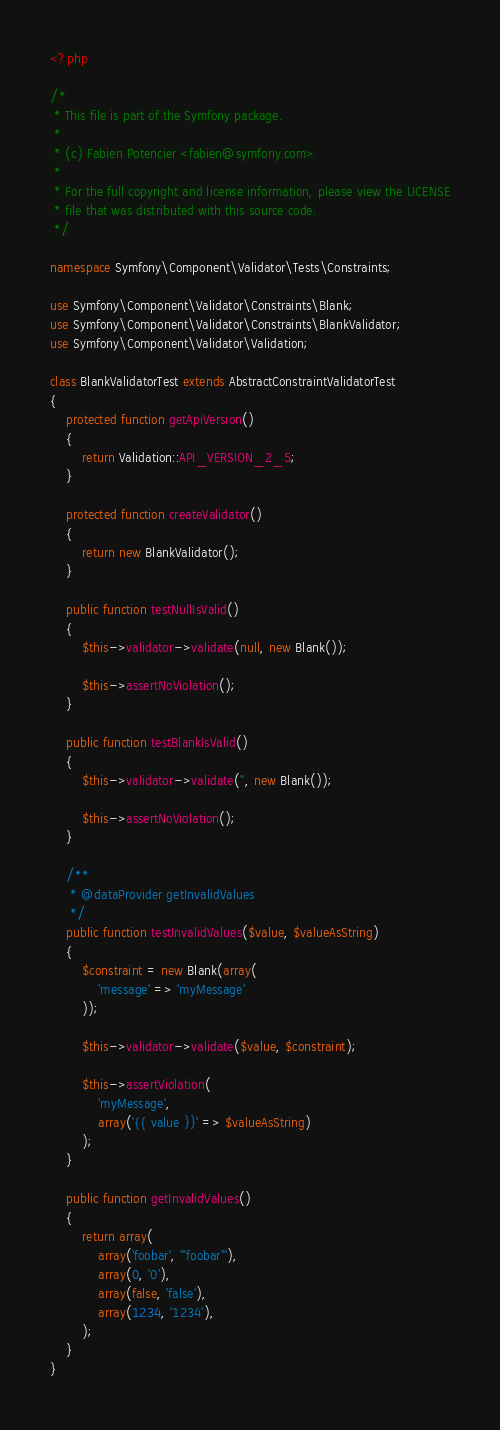Convert code to text. <code><loc_0><loc_0><loc_500><loc_500><_PHP_><?php

/*
 * This file is part of the Symfony package.
 *
 * (c) Fabien Potencier <fabien@symfony.com>
 *
 * For the full copyright and license information, please view the LICENSE
 * file that was distributed with this source code.
 */

namespace Symfony\Component\Validator\Tests\Constraints;

use Symfony\Component\Validator\Constraints\Blank;
use Symfony\Component\Validator\Constraints\BlankValidator;
use Symfony\Component\Validator\Validation;

class BlankValidatorTest extends AbstractConstraintValidatorTest
{
    protected function getApiVersion()
    {
        return Validation::API_VERSION_2_5;
    }

    protected function createValidator()
    {
        return new BlankValidator();
    }

    public function testNullIsValid()
    {
        $this->validator->validate(null, new Blank());

        $this->assertNoViolation();
    }

    public function testBlankIsValid()
    {
        $this->validator->validate('', new Blank());

        $this->assertNoViolation();
    }

    /**
     * @dataProvider getInvalidValues
     */
    public function testInvalidValues($value, $valueAsString)
    {
        $constraint = new Blank(array(
            'message' => 'myMessage'
        ));

        $this->validator->validate($value, $constraint);

        $this->assertViolation(
            'myMessage',
            array('{{ value }}' => $valueAsString)
        );
    }

    public function getInvalidValues()
    {
        return array(
            array('foobar', '"foobar"'),
            array(0, '0'),
            array(false, 'false'),
            array(1234, '1234'),
        );
    }
}
</code> 